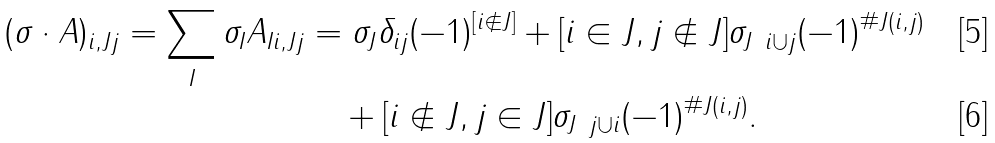<formula> <loc_0><loc_0><loc_500><loc_500>( \sigma \cdot A ) _ { i , J j } = \sum _ { I } \sigma _ { I } A _ { I i , J j } & = \sigma _ { J } \delta _ { i j } ( - 1 ) ^ { [ i \notin J ] } + [ i \in J , j \notin J ] \sigma _ { J \ i \cup j } ( - 1 ) ^ { \# J ( i , j ) } \\ & \quad + [ i \notin J , j \in J ] \sigma _ { J \ j \cup i } ( - 1 ) ^ { \# J ( i , j ) } .</formula> 